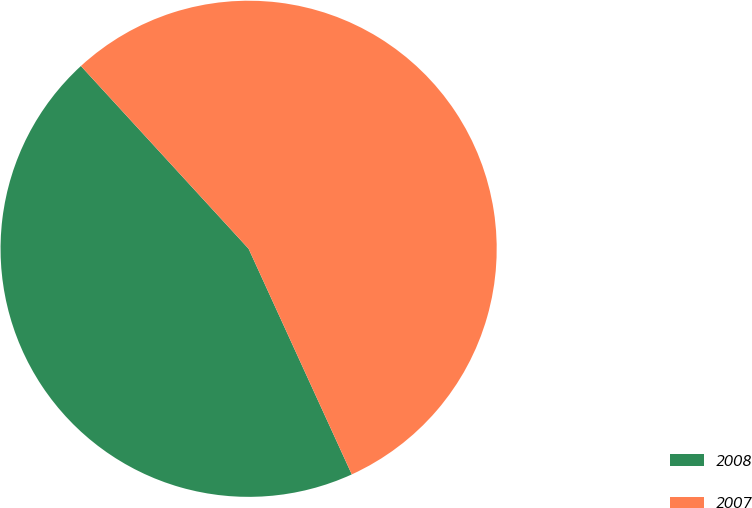Convert chart. <chart><loc_0><loc_0><loc_500><loc_500><pie_chart><fcel>2008<fcel>2007<nl><fcel>45.01%<fcel>54.99%<nl></chart> 